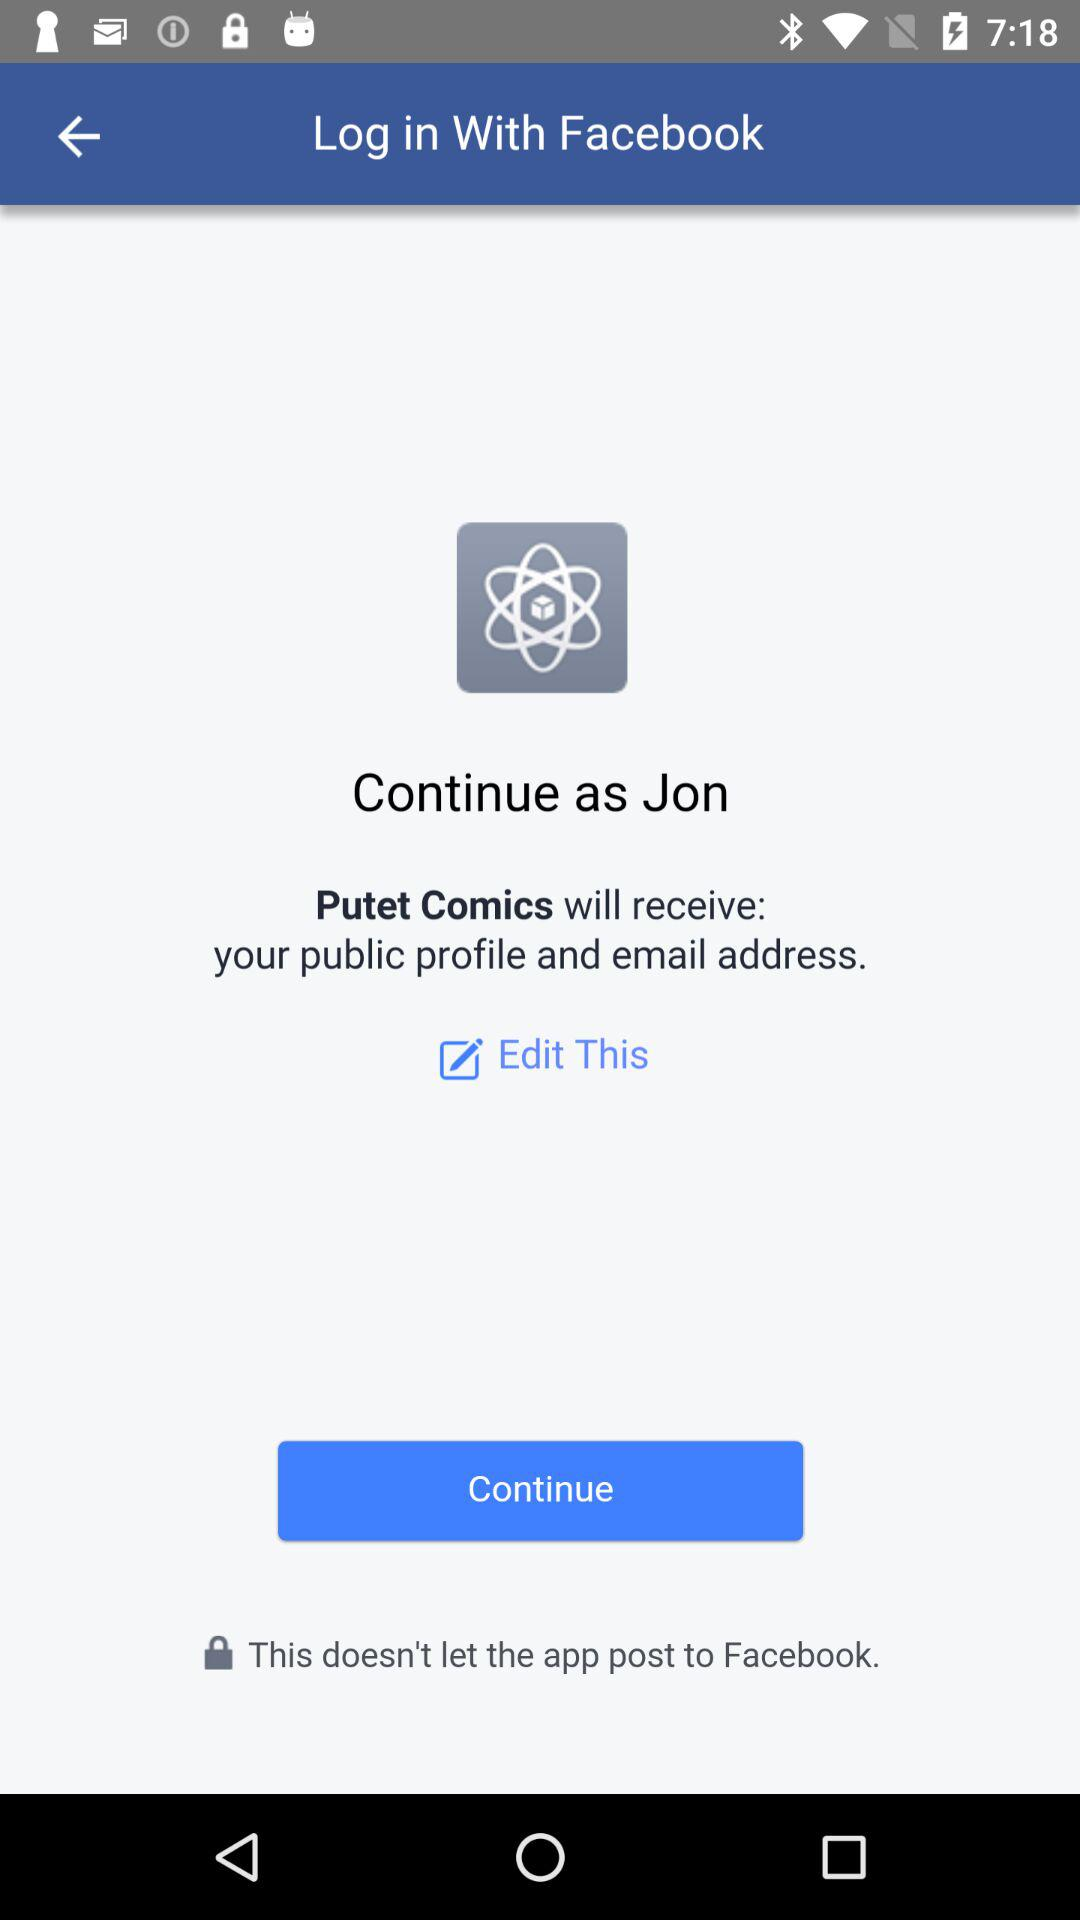What application is used for login? The application that is used for login is "Facebook". 